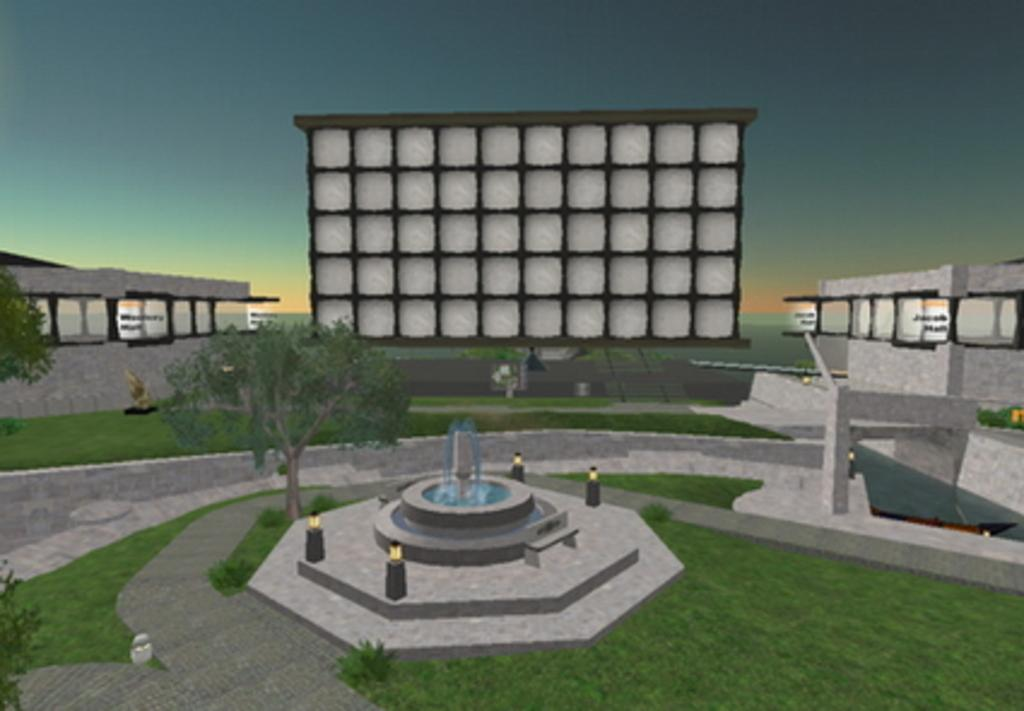What type of vegetation is present in the image? There is a tree in the image. What type of structures can be seen in the image? There are buildings in the image. What is the ground covered with in the image? There is grass in the image. What type of water feature is present in the image? There is a fountain in the image. How many buttons are attached to the tree in the image? There are no buttons present on the tree in the image. What type of light source is illuminating the fountain in the image? There is no light source mentioned or visible in the image; it only shows a fountain. 